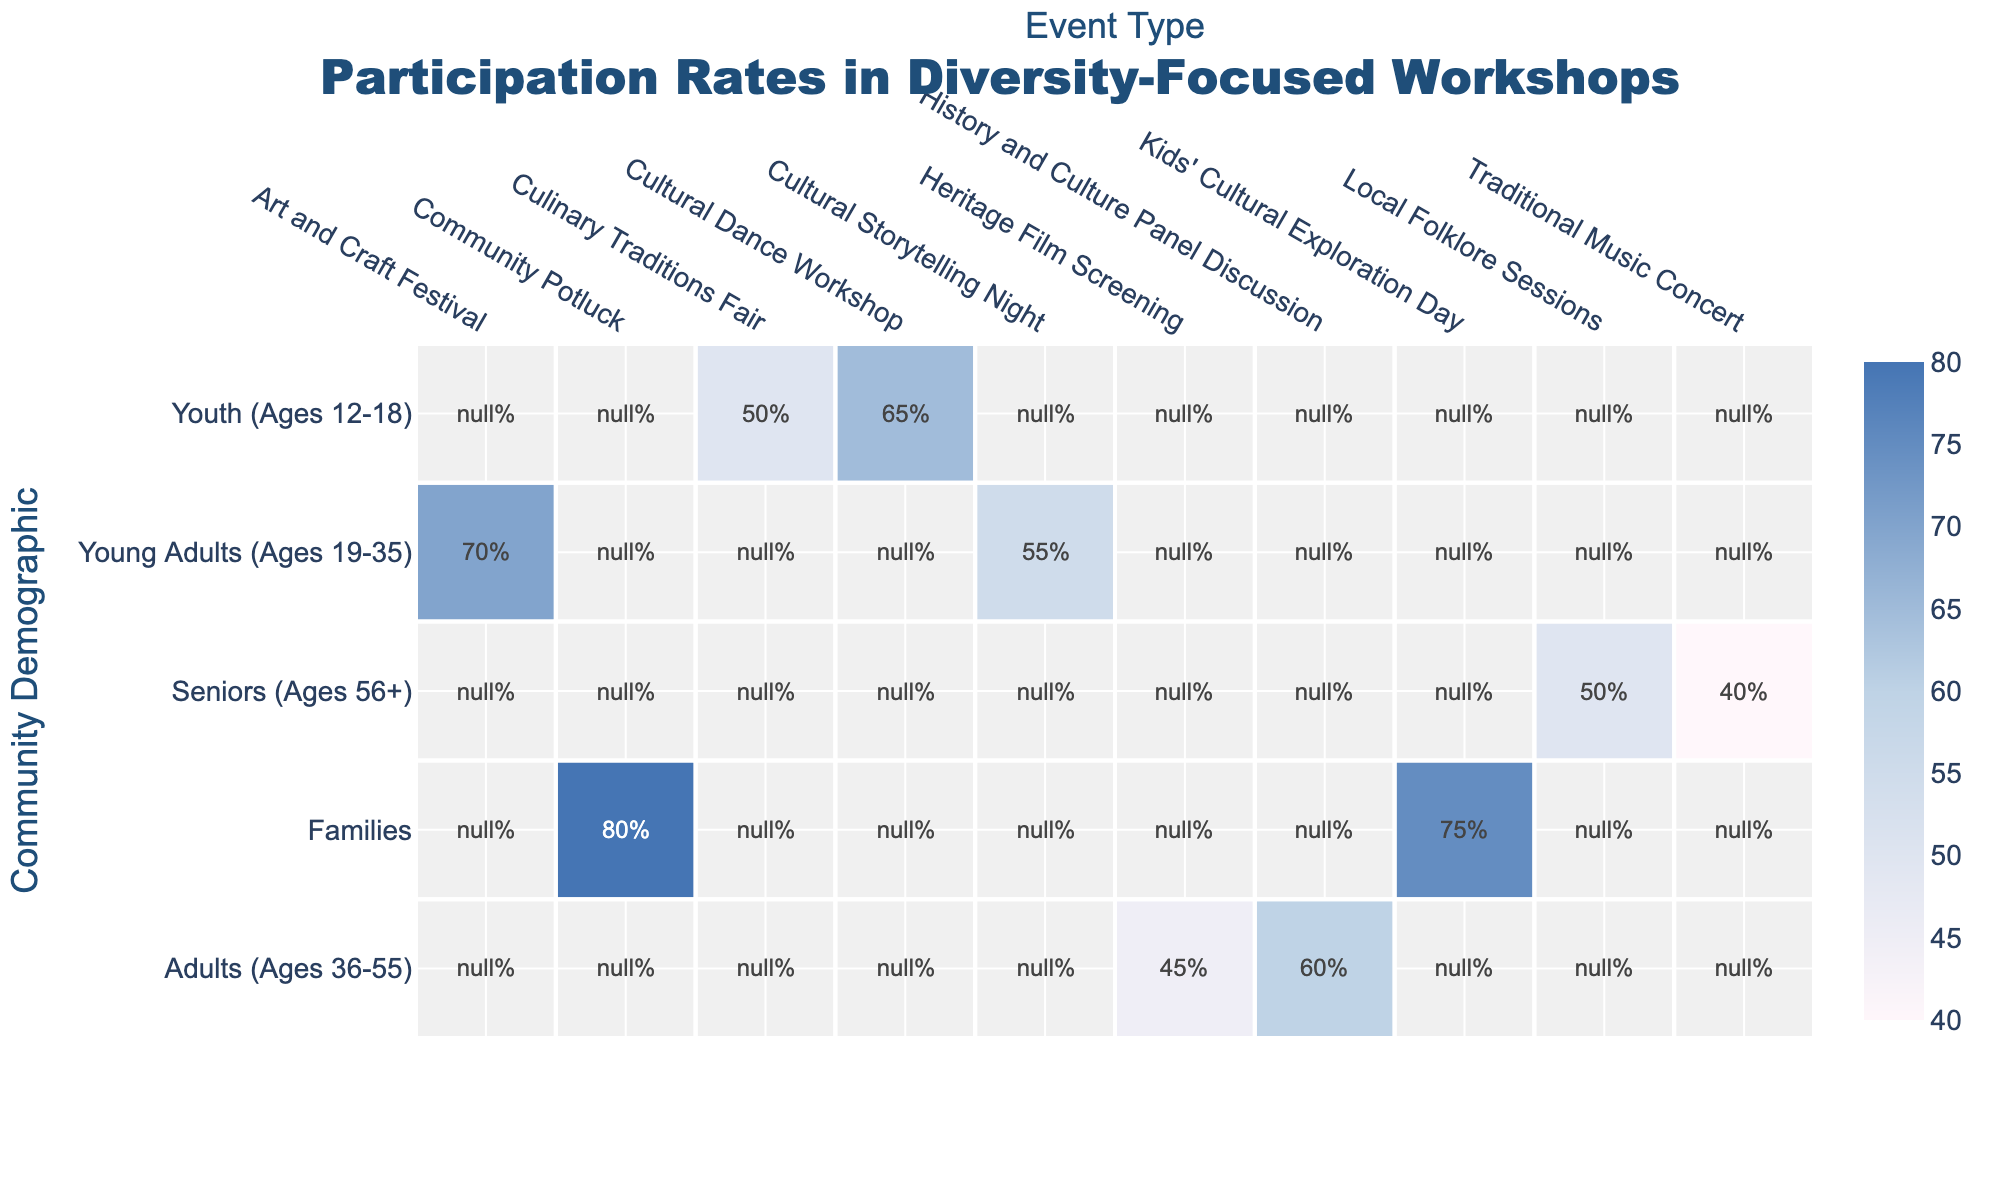What is the participation rate for Youth in the Cultural Dance Workshop? The participation rate for Youth in the Cultural Dance Workshop is clearly indicated in the table as 65%.
Answer: 65% Which event had the highest participation rate and what was that rate? The Community Potluck had the highest participation rate at 80%, as noted in the table.
Answer: 80% Is the participation rate for Seniors in the Traditional Music Concert higher than in the Local Folklore Sessions? The participation rate for Seniors in the Traditional Music Concert is 40%, which is lower than the 50% participation rate for the Local Folklore Sessions.
Answer: No What is the average participation rate for Families across the two events listed? The participation rates for Families are 80% (Community Potluck) and 75% (Kids' Cultural Exploration Day). The average is (80 + 75) / 2 = 77.5%.
Answer: 77.5% Which demographic group showed the least participation in any event listed? The least participation rate among demographic groups is 40% for Seniors in the Traditional Music Concert, which is lower than all other rates in the table.
Answer: Seniors What is the total participation rate for Young Adults in both events listed? The participation rates for Young Adults in the Art and Craft Festival and Cultural Storytelling Night are 70% and 55%, respectively. Adding these gives: 70 + 55 = 125%.
Answer: 125% Did Adults have a higher participation rate in the History and Culture Panel Discussion compared to the Heritage Film Screening? Yes, the participation rate for Adults in the History and Culture Panel Discussion is 60%, which is higher than the 45% in the Heritage Film Screening.
Answer: Yes What is the difference in participation rates between Families and Youth in the Culinary Traditions Fair? Families do not participate in the Culinary Traditions Fair, which has a participation rate of 50% for Youth. Therefore, the difference is 0 - 50 = -50%.
Answer: -50% 